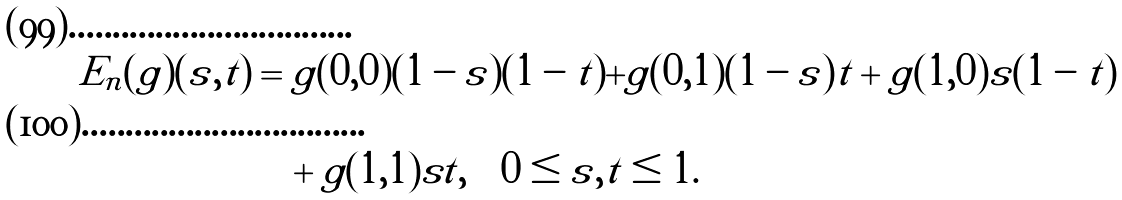Convert formula to latex. <formula><loc_0><loc_0><loc_500><loc_500>E _ { n } ( g ) ( s , t ) & = g ( 0 , 0 ) ( 1 - s ) ( 1 - t ) + g ( 0 , 1 ) ( 1 - s ) t + g ( 1 , 0 ) s ( 1 - t ) \\ & \quad + g ( 1 , 1 ) s t , \quad 0 \leq s , t \leq 1 .</formula> 